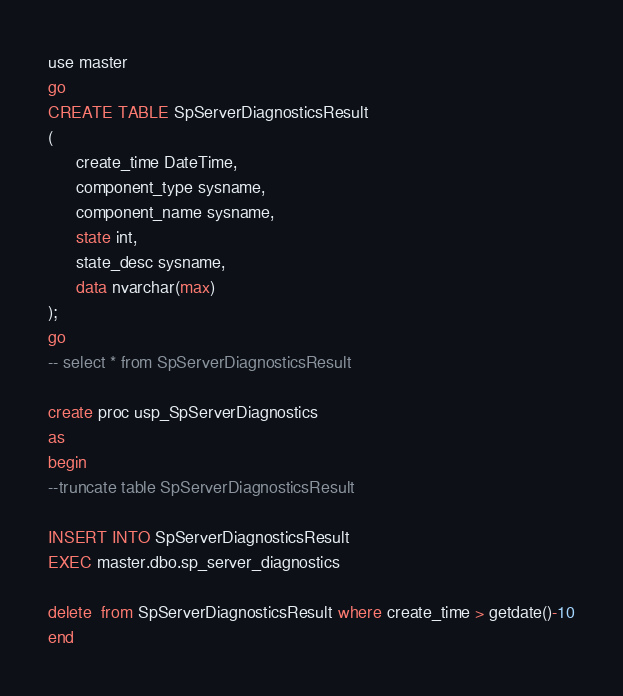Convert code to text. <code><loc_0><loc_0><loc_500><loc_500><_SQL_>
use master
go
CREATE TABLE SpServerDiagnosticsResult  
(  
      create_time DateTime,  
      component_type sysname,  
      component_name sysname,  
      state int,  
      state_desc sysname,  
      data nvarchar(max)  
);  
go
-- select * from SpServerDiagnosticsResult

create proc usp_SpServerDiagnostics
as 
begin
--truncate table SpServerDiagnosticsResult

INSERT INTO SpServerDiagnosticsResult 
EXEC master.dbo.sp_server_diagnostics

delete  from SpServerDiagnosticsResult where create_time > getdate()-10
end</code> 